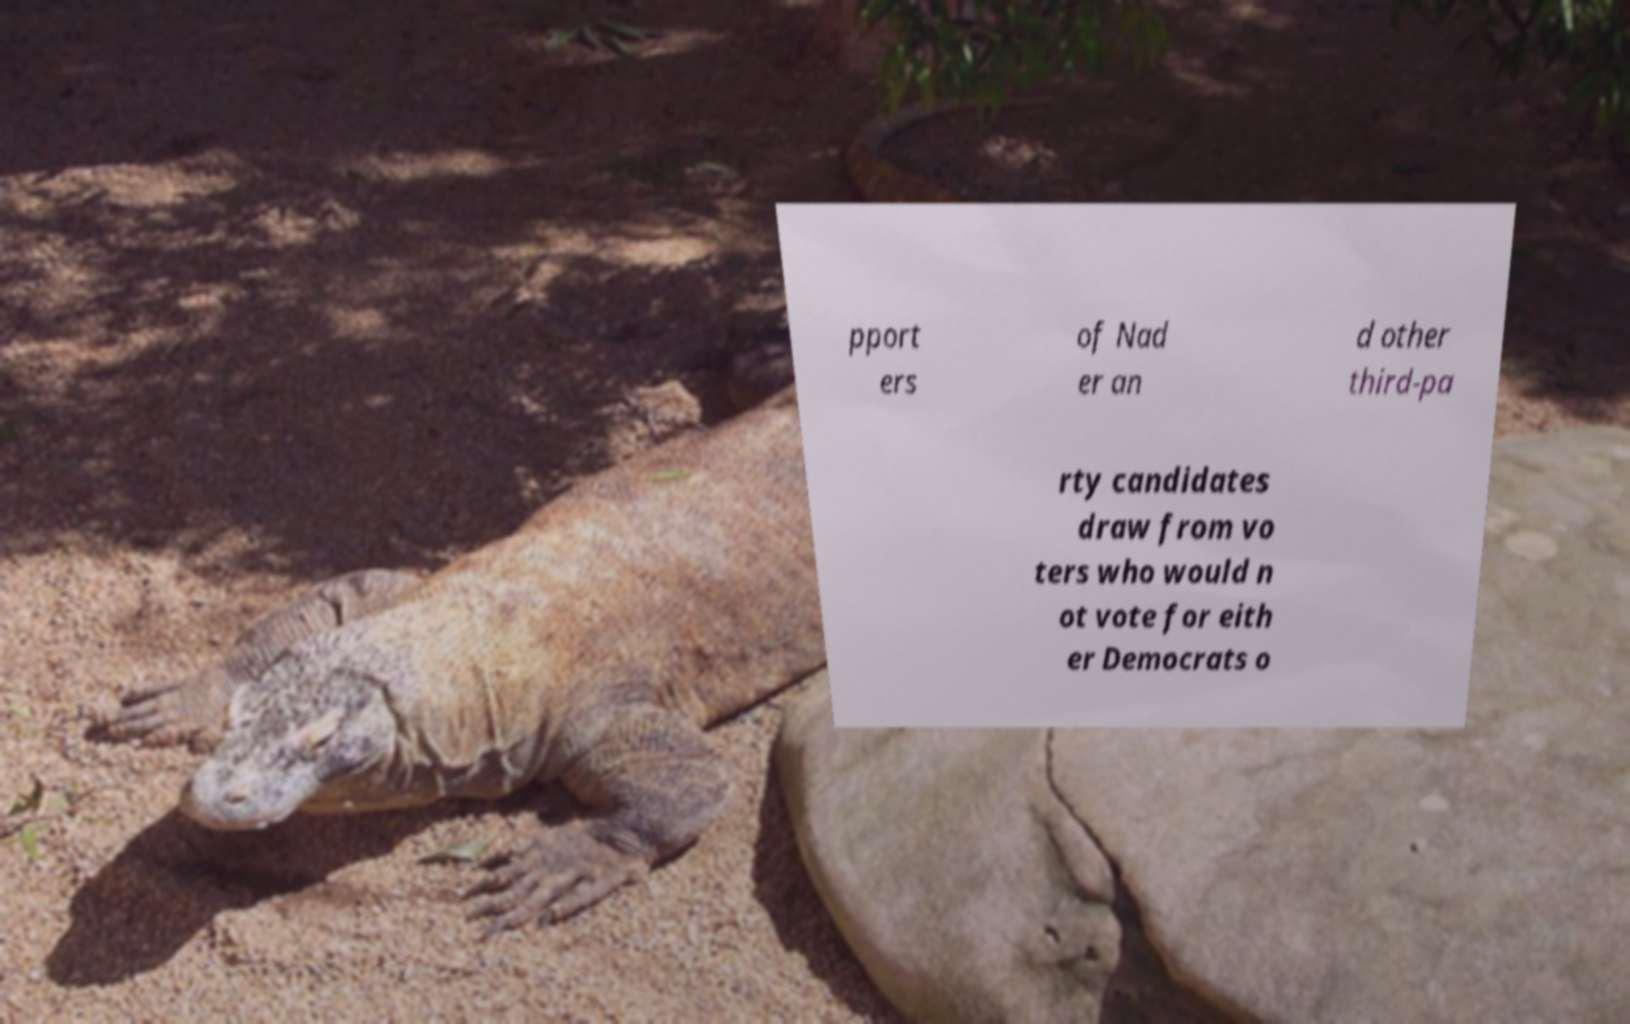Please read and relay the text visible in this image. What does it say? pport ers of Nad er an d other third-pa rty candidates draw from vo ters who would n ot vote for eith er Democrats o 